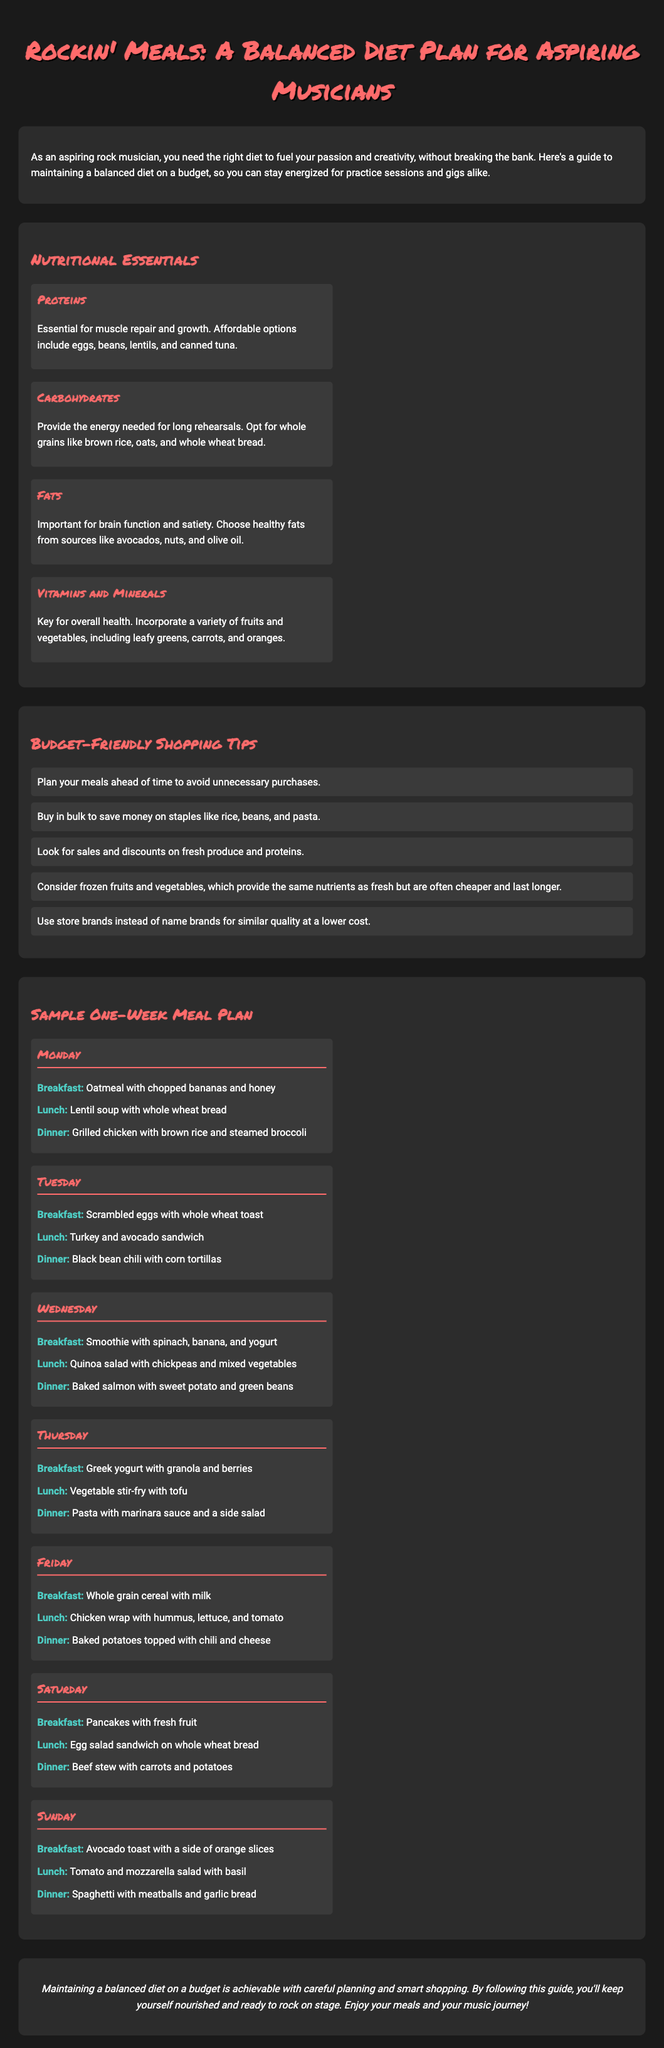What is the title of the meal plan? The title of the meal plan is prominently displayed at the beginning of the document.
Answer: Rockin' Meals: A Balanced Diet Plan for Aspiring Musicians What are two protein sources mentioned? The document lists affordable protein sources in the Nutritional Essentials section.
Answer: Eggs, beans What is recommended for breakfast on Tuesday? The meal for breakfast on Tuesday is specified in the Sample One-Week Meal Plan section.
Answer: Scrambled eggs with whole wheat toast How many days are included in the sample meal plan? The meal plan outlines meals for each day of the week, indicating the total number of days.
Answer: Seven What is a suggested shopping tip for aspiring musicians? The document provides several tips for budget-friendly shopping in the appropriate section.
Answer: Buy in bulk What type of fat is suggested in the Nutritional Essentials section? The type of fat that is emphasized can be found in the description under the Fats heading.
Answer: Healthy fats What meal is served for dinner on Saturday? The dinner for Saturday is clearly listed in the Sample One-Week Meal Plan section.
Answer: Beef stew with carrots and potatoes Which fruit is mentioned for breakfast on Sunday? The specific fruit for breakfast on Sunday is outlined in the meal plan.
Answer: Orange slices Which food group is recommended to be included for brain function? The document specifies the importance of this food group under the Fats category.
Answer: Healthy fats 